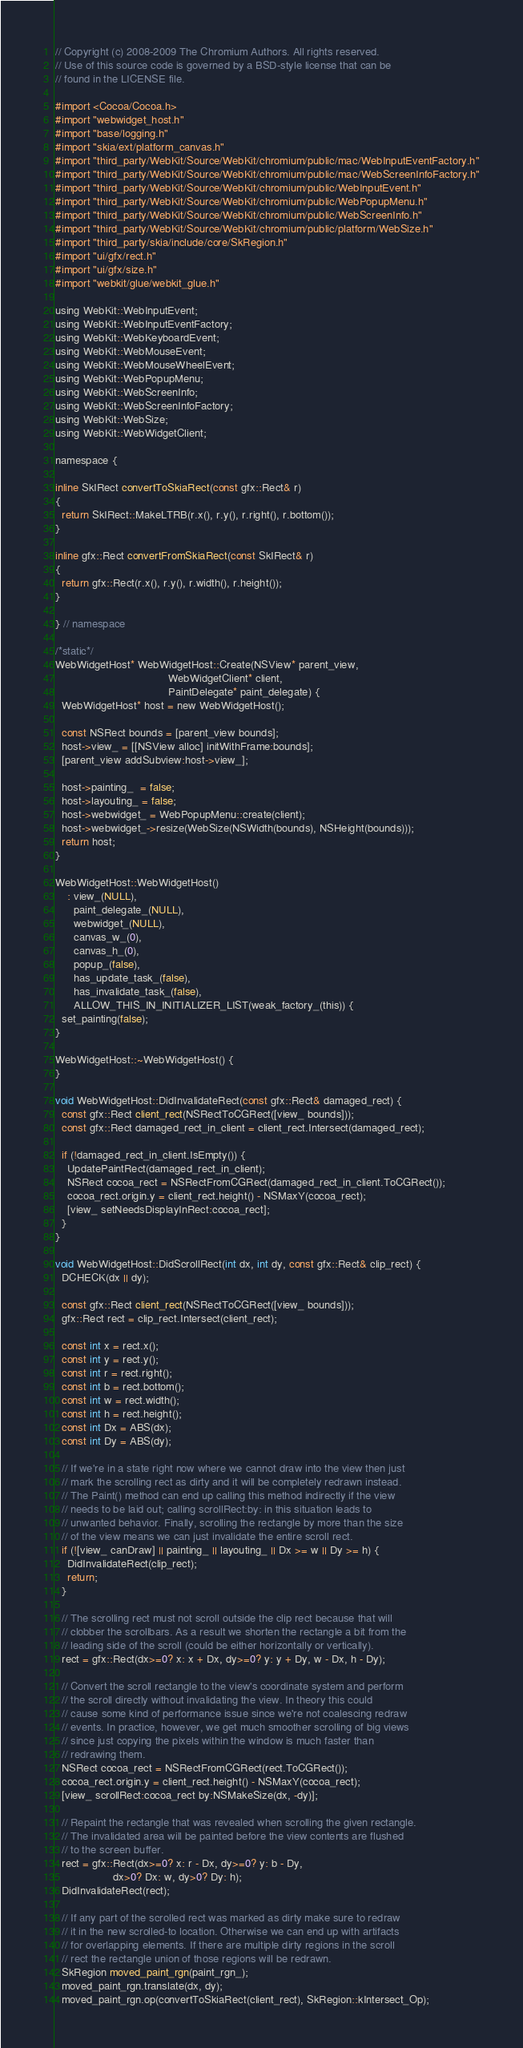Convert code to text. <code><loc_0><loc_0><loc_500><loc_500><_ObjectiveC_>// Copyright (c) 2008-2009 The Chromium Authors. All rights reserved.
// Use of this source code is governed by a BSD-style license that can be
// found in the LICENSE file.

#import <Cocoa/Cocoa.h>
#import "webwidget_host.h"
#import "base/logging.h"
#import "skia/ext/platform_canvas.h"
#import "third_party/WebKit/Source/WebKit/chromium/public/mac/WebInputEventFactory.h"
#import "third_party/WebKit/Source/WebKit/chromium/public/mac/WebScreenInfoFactory.h"
#import "third_party/WebKit/Source/WebKit/chromium/public/WebInputEvent.h"
#import "third_party/WebKit/Source/WebKit/chromium/public/WebPopupMenu.h"
#import "third_party/WebKit/Source/WebKit/chromium/public/WebScreenInfo.h"
#import "third_party/WebKit/Source/WebKit/chromium/public/platform/WebSize.h"
#import "third_party/skia/include/core/SkRegion.h"
#import "ui/gfx/rect.h"
#import "ui/gfx/size.h"
#import "webkit/glue/webkit_glue.h"

using WebKit::WebInputEvent;
using WebKit::WebInputEventFactory;
using WebKit::WebKeyboardEvent;
using WebKit::WebMouseEvent;
using WebKit::WebMouseWheelEvent;
using WebKit::WebPopupMenu;
using WebKit::WebScreenInfo;
using WebKit::WebScreenInfoFactory;
using WebKit::WebSize;
using WebKit::WebWidgetClient;

namespace {

inline SkIRect convertToSkiaRect(const gfx::Rect& r)
{
  return SkIRect::MakeLTRB(r.x(), r.y(), r.right(), r.bottom());
}

inline gfx::Rect convertFromSkiaRect(const SkIRect& r)
{
  return gfx::Rect(r.x(), r.y(), r.width(), r.height());
}

} // namespace

/*static*/
WebWidgetHost* WebWidgetHost::Create(NSView* parent_view,
                                     WebWidgetClient* client,
                                     PaintDelegate* paint_delegate) {
  WebWidgetHost* host = new WebWidgetHost();

  const NSRect bounds = [parent_view bounds];
  host->view_ = [[NSView alloc] initWithFrame:bounds];
  [parent_view addSubview:host->view_];

  host->painting_  = false;
  host->layouting_ = false;
  host->webwidget_ = WebPopupMenu::create(client);
  host->webwidget_->resize(WebSize(NSWidth(bounds), NSHeight(bounds)));
  return host;
}

WebWidgetHost::WebWidgetHost()
    : view_(NULL),
      paint_delegate_(NULL),
      webwidget_(NULL),
      canvas_w_(0),
      canvas_h_(0),
      popup_(false),
      has_update_task_(false),
      has_invalidate_task_(false),
      ALLOW_THIS_IN_INITIALIZER_LIST(weak_factory_(this)) {
  set_painting(false);
}

WebWidgetHost::~WebWidgetHost() {
}

void WebWidgetHost::DidInvalidateRect(const gfx::Rect& damaged_rect) {
  const gfx::Rect client_rect(NSRectToCGRect([view_ bounds]));
  const gfx::Rect damaged_rect_in_client = client_rect.Intersect(damaged_rect);

  if (!damaged_rect_in_client.IsEmpty()) {
    UpdatePaintRect(damaged_rect_in_client);
    NSRect cocoa_rect = NSRectFromCGRect(damaged_rect_in_client.ToCGRect());
    cocoa_rect.origin.y = client_rect.height() - NSMaxY(cocoa_rect);
    [view_ setNeedsDisplayInRect:cocoa_rect];
  }
}

void WebWidgetHost::DidScrollRect(int dx, int dy, const gfx::Rect& clip_rect) {
  DCHECK(dx || dy);

  const gfx::Rect client_rect(NSRectToCGRect([view_ bounds]));
  gfx::Rect rect = clip_rect.Intersect(client_rect);

  const int x = rect.x();
  const int y = rect.y();
  const int r = rect.right();
  const int b = rect.bottom();
  const int w = rect.width();
  const int h = rect.height();
  const int Dx = ABS(dx);
  const int Dy = ABS(dy);

  // If we're in a state right now where we cannot draw into the view then just
  // mark the scrolling rect as dirty and it will be completely redrawn instead.
  // The Paint() method can end up calling this method indirectly if the view
  // needs to be laid out; calling scrollRect:by: in this situation leads to
  // unwanted behavior. Finally, scrolling the rectangle by more than the size
  // of the view means we can just invalidate the entire scroll rect.
  if (![view_ canDraw] || painting_ || layouting_ || Dx >= w || Dy >= h) {
    DidInvalidateRect(clip_rect);
    return;
  }

  // The scrolling rect must not scroll outside the clip rect because that will
  // clobber the scrollbars. As a result we shorten the rectangle a bit from the
  // leading side of the scroll (could be either horizontally or vertically).
  rect = gfx::Rect(dx>=0? x: x + Dx, dy>=0? y: y + Dy, w - Dx, h - Dy);

  // Convert the scroll rectangle to the view's coordinate system and perform
  // the scroll directly without invalidating the view. In theory this could
  // cause some kind of performance issue since we're not coalescing redraw
  // events. In practice, however, we get much smoother scrolling of big views
  // since just copying the pixels within the window is much faster than
  // redrawing them.
  NSRect cocoa_rect = NSRectFromCGRect(rect.ToCGRect());
  cocoa_rect.origin.y = client_rect.height() - NSMaxY(cocoa_rect);
  [view_ scrollRect:cocoa_rect by:NSMakeSize(dx, -dy)];

  // Repaint the rectangle that was revealed when scrolling the given rectangle.
  // The invalidated area will be painted before the view contents are flushed
  // to the screen buffer.
  rect = gfx::Rect(dx>=0? x: r - Dx, dy>=0? y: b - Dy,
                   dx>0? Dx: w, dy>0? Dy: h);
  DidInvalidateRect(rect);

  // If any part of the scrolled rect was marked as dirty make sure to redraw
  // it in the new scrolled-to location. Otherwise we can end up with artifacts
  // for overlapping elements. If there are multiple dirty regions in the scroll
  // rect the rectangle union of those regions will be redrawn.
  SkRegion moved_paint_rgn(paint_rgn_);
  moved_paint_rgn.translate(dx, dy);
  moved_paint_rgn.op(convertToSkiaRect(client_rect), SkRegion::kIntersect_Op);</code> 